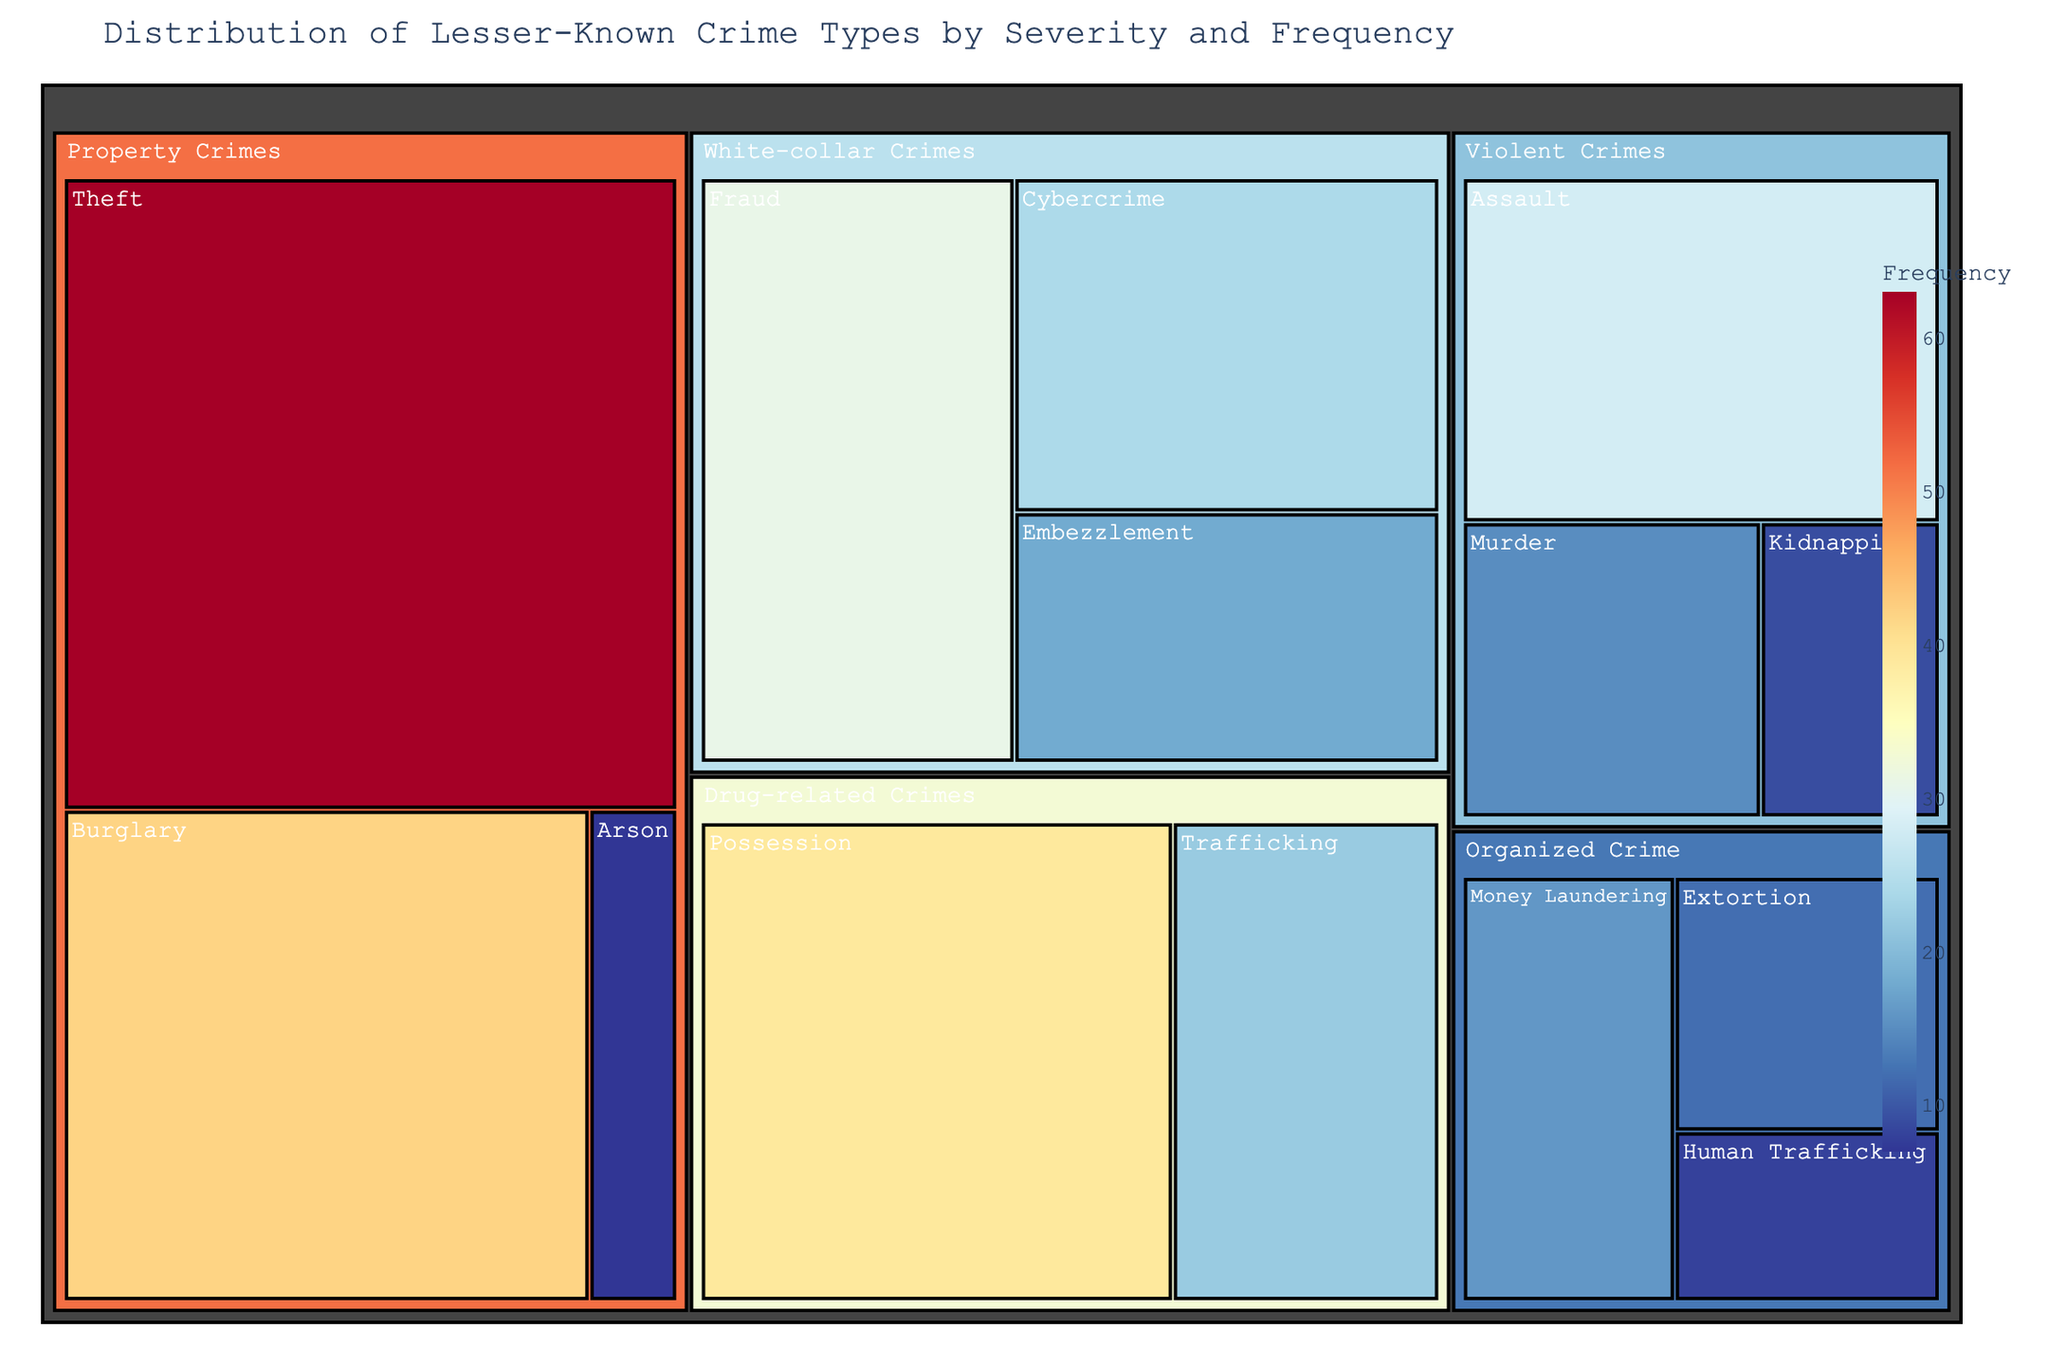What is the title of the treemap? The title of the treemap is located at the top of the figure and provides a clear overview of what the chart represents.
Answer: Distribution of Lesser-Known Crime Types by Severity and Frequency Which subcategory under "Property Crimes" has the highest frequency? By observing the "Property Crimes" category, the size of each subcategory's box indicates its frequency. The largest box represents the highest frequency.
Answer: Theft How many subcategories are there under "White-collar Crimes"? The number of subcategories can be counted by identifying the different segments under the "White-collar Crimes" category.
Answer: 3 Which subcategory has the smallest value, and what is that value? Each subcategory's size is proportional to its value. The smallest box indicates the smallest value.
Answer: Arson, 7 How does the frequency of "Assault" compare to "Possession" in drug-related crimes? By looking at the sizes of the "Assault" and "Possession" boxes, the larger box indicates a higher value.
Answer: Possession is higher What is the total frequency of Organized Crime categories? Add the frequencies of all subcategories under "Organized Crime": Extortion (12), Money Laundering (16), and Human Trafficking (8). 12 + 16 + 8 = 36
Answer: 36 Which category has the highest overall frequency, and what is the value? Sum the values of all subcategories in each category, and identify the category with the highest total.
Answer: Property Crimes, 112 Compare the frequency values of "Fraud" and "Burglary". Which one is higher and by how much? Subtract the frequency value of "Fraud" (31) from "Burglary" (42). 42 - 31 = 11
Answer: Burglary, by 11 What is the average frequency of all subcategories in "Violent Crimes"? Add the frequencies of all subcategories in "Violent Crimes": Murder (15), Assault (28), Kidnapping (9). The total is 15 + 28 + 9 = 52. Divide 52 by the number of subcategories (3). 52 / 3 ≈ 17.33
Answer: 17.33 Among all subcategories under "Drug-related Crimes", which one has the highest frequency? Identify the largest box under "Drug-related Crimes", which indicates the highest frequency.
Answer: Possession 